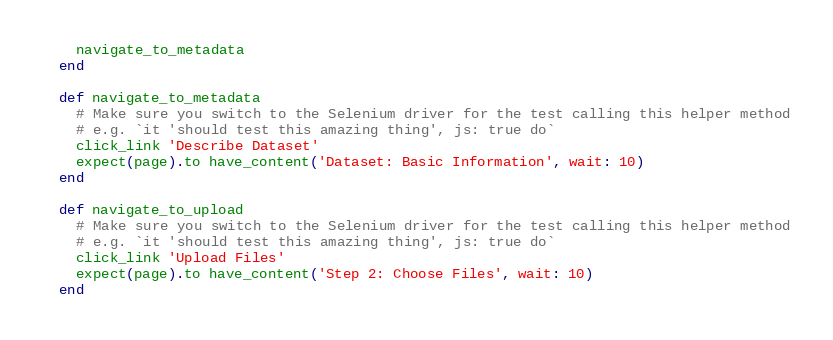Convert code to text. <code><loc_0><loc_0><loc_500><loc_500><_Ruby_>    navigate_to_metadata
  end

  def navigate_to_metadata
    # Make sure you switch to the Selenium driver for the test calling this helper method
    # e.g. `it 'should test this amazing thing', js: true do`
    click_link 'Describe Dataset'
    expect(page).to have_content('Dataset: Basic Information', wait: 10)
  end

  def navigate_to_upload
    # Make sure you switch to the Selenium driver for the test calling this helper method
    # e.g. `it 'should test this amazing thing', js: true do`
    click_link 'Upload Files'
    expect(page).to have_content('Step 2: Choose Files', wait: 10)
  end
</code> 